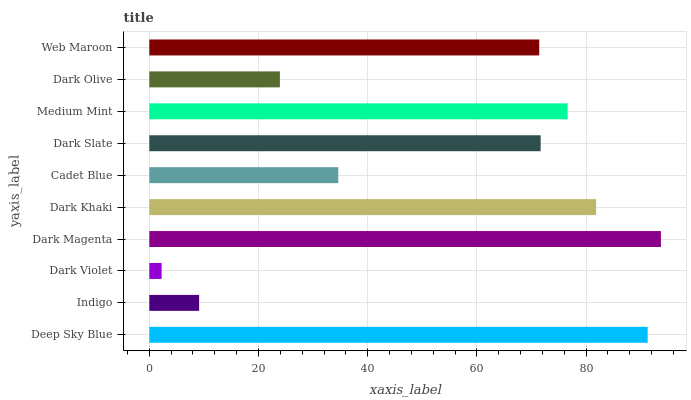Is Dark Violet the minimum?
Answer yes or no. Yes. Is Dark Magenta the maximum?
Answer yes or no. Yes. Is Indigo the minimum?
Answer yes or no. No. Is Indigo the maximum?
Answer yes or no. No. Is Deep Sky Blue greater than Indigo?
Answer yes or no. Yes. Is Indigo less than Deep Sky Blue?
Answer yes or no. Yes. Is Indigo greater than Deep Sky Blue?
Answer yes or no. No. Is Deep Sky Blue less than Indigo?
Answer yes or no. No. Is Dark Slate the high median?
Answer yes or no. Yes. Is Web Maroon the low median?
Answer yes or no. Yes. Is Deep Sky Blue the high median?
Answer yes or no. No. Is Dark Slate the low median?
Answer yes or no. No. 